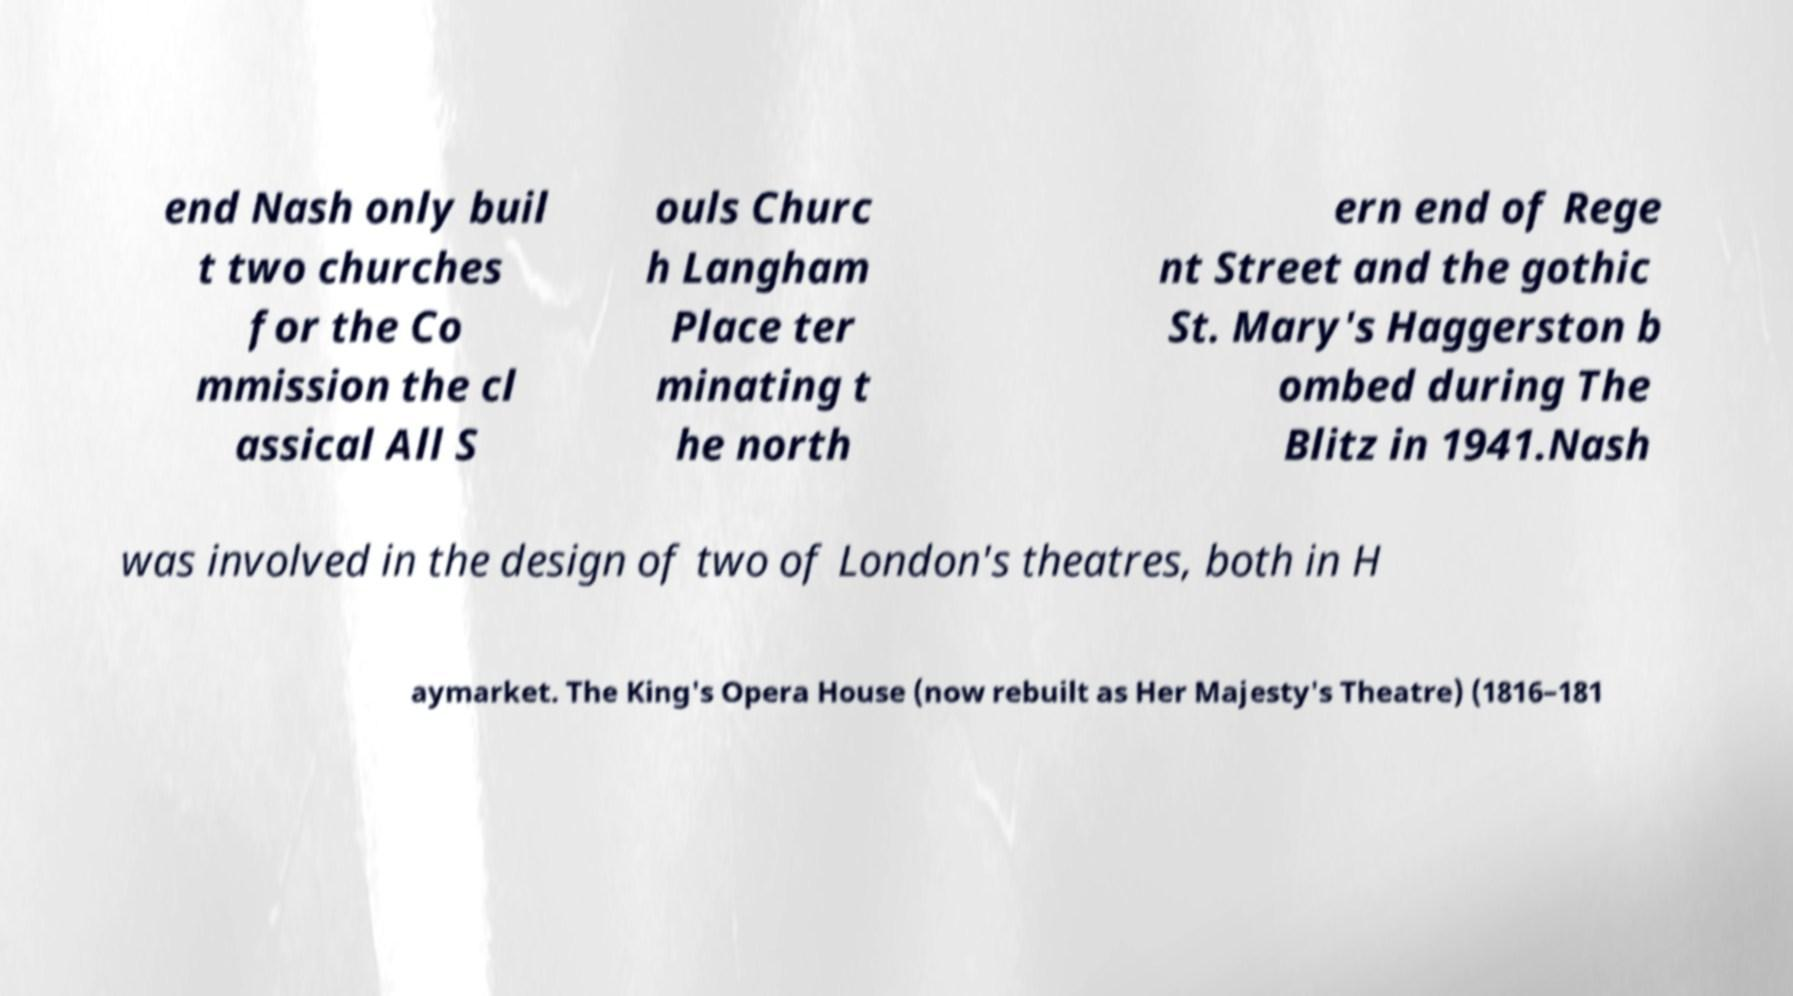Please read and relay the text visible in this image. What does it say? end Nash only buil t two churches for the Co mmission the cl assical All S ouls Churc h Langham Place ter minating t he north ern end of Rege nt Street and the gothic St. Mary's Haggerston b ombed during The Blitz in 1941.Nash was involved in the design of two of London's theatres, both in H aymarket. The King's Opera House (now rebuilt as Her Majesty's Theatre) (1816–181 